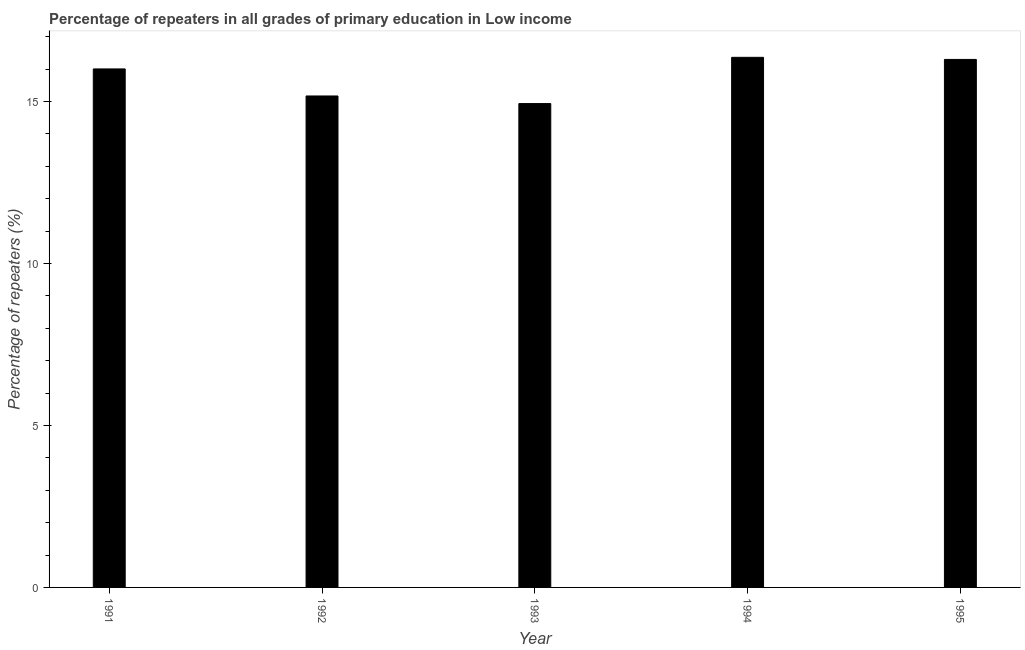Does the graph contain any zero values?
Make the answer very short. No. Does the graph contain grids?
Your answer should be compact. No. What is the title of the graph?
Ensure brevity in your answer.  Percentage of repeaters in all grades of primary education in Low income. What is the label or title of the Y-axis?
Keep it short and to the point. Percentage of repeaters (%). What is the percentage of repeaters in primary education in 1992?
Offer a terse response. 15.17. Across all years, what is the maximum percentage of repeaters in primary education?
Your answer should be very brief. 16.37. Across all years, what is the minimum percentage of repeaters in primary education?
Offer a very short reply. 14.94. In which year was the percentage of repeaters in primary education minimum?
Make the answer very short. 1993. What is the sum of the percentage of repeaters in primary education?
Offer a very short reply. 78.79. What is the difference between the percentage of repeaters in primary education in 1992 and 1995?
Your response must be concise. -1.13. What is the average percentage of repeaters in primary education per year?
Offer a very short reply. 15.76. What is the median percentage of repeaters in primary education?
Provide a short and direct response. 16.01. What is the ratio of the percentage of repeaters in primary education in 1992 to that in 1994?
Make the answer very short. 0.93. What is the difference between the highest and the second highest percentage of repeaters in primary education?
Provide a succinct answer. 0.07. Is the sum of the percentage of repeaters in primary education in 1993 and 1995 greater than the maximum percentage of repeaters in primary education across all years?
Provide a succinct answer. Yes. What is the difference between the highest and the lowest percentage of repeaters in primary education?
Offer a very short reply. 1.43. How many years are there in the graph?
Your answer should be very brief. 5. Are the values on the major ticks of Y-axis written in scientific E-notation?
Provide a short and direct response. No. What is the Percentage of repeaters (%) of 1991?
Give a very brief answer. 16.01. What is the Percentage of repeaters (%) of 1992?
Provide a short and direct response. 15.17. What is the Percentage of repeaters (%) in 1993?
Make the answer very short. 14.94. What is the Percentage of repeaters (%) in 1994?
Keep it short and to the point. 16.37. What is the Percentage of repeaters (%) in 1995?
Keep it short and to the point. 16.3. What is the difference between the Percentage of repeaters (%) in 1991 and 1992?
Your response must be concise. 0.83. What is the difference between the Percentage of repeaters (%) in 1991 and 1993?
Ensure brevity in your answer.  1.07. What is the difference between the Percentage of repeaters (%) in 1991 and 1994?
Offer a terse response. -0.36. What is the difference between the Percentage of repeaters (%) in 1991 and 1995?
Your response must be concise. -0.29. What is the difference between the Percentage of repeaters (%) in 1992 and 1993?
Give a very brief answer. 0.23. What is the difference between the Percentage of repeaters (%) in 1992 and 1994?
Your response must be concise. -1.19. What is the difference between the Percentage of repeaters (%) in 1992 and 1995?
Keep it short and to the point. -1.13. What is the difference between the Percentage of repeaters (%) in 1993 and 1994?
Ensure brevity in your answer.  -1.43. What is the difference between the Percentage of repeaters (%) in 1993 and 1995?
Provide a short and direct response. -1.36. What is the difference between the Percentage of repeaters (%) in 1994 and 1995?
Your response must be concise. 0.06. What is the ratio of the Percentage of repeaters (%) in 1991 to that in 1992?
Ensure brevity in your answer.  1.05. What is the ratio of the Percentage of repeaters (%) in 1991 to that in 1993?
Keep it short and to the point. 1.07. What is the ratio of the Percentage of repeaters (%) in 1991 to that in 1994?
Give a very brief answer. 0.98. What is the ratio of the Percentage of repeaters (%) in 1992 to that in 1994?
Give a very brief answer. 0.93. What is the ratio of the Percentage of repeaters (%) in 1992 to that in 1995?
Provide a succinct answer. 0.93. What is the ratio of the Percentage of repeaters (%) in 1993 to that in 1994?
Provide a succinct answer. 0.91. What is the ratio of the Percentage of repeaters (%) in 1993 to that in 1995?
Offer a very short reply. 0.92. What is the ratio of the Percentage of repeaters (%) in 1994 to that in 1995?
Give a very brief answer. 1. 